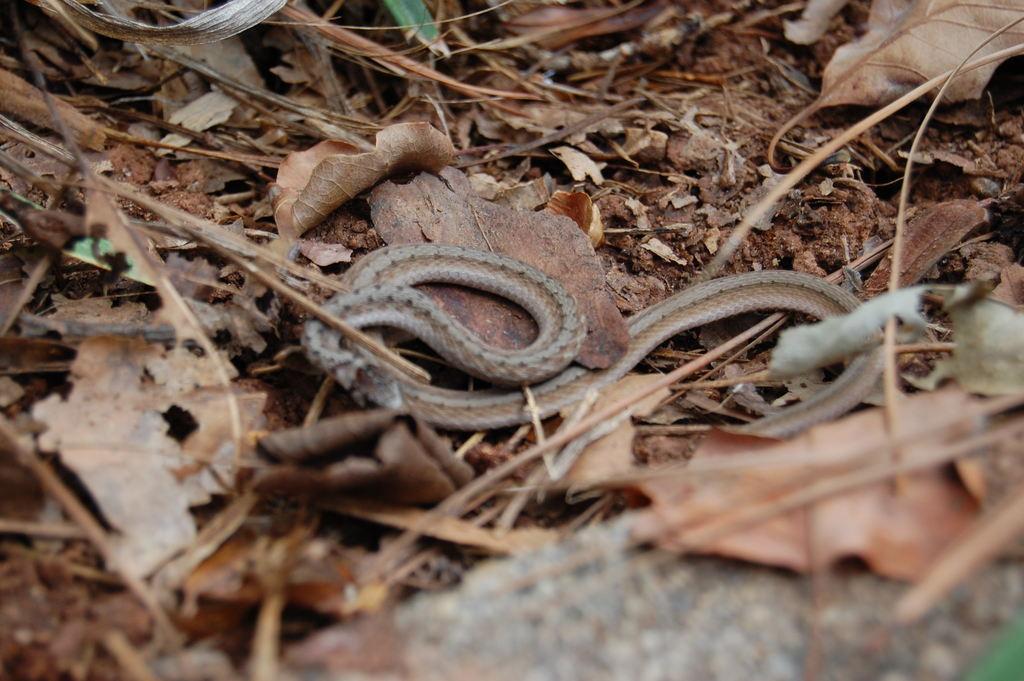Describe this image in one or two sentences. In the middle I can see a snake, leaves and sticks. This image is taken on the ground during a day. 